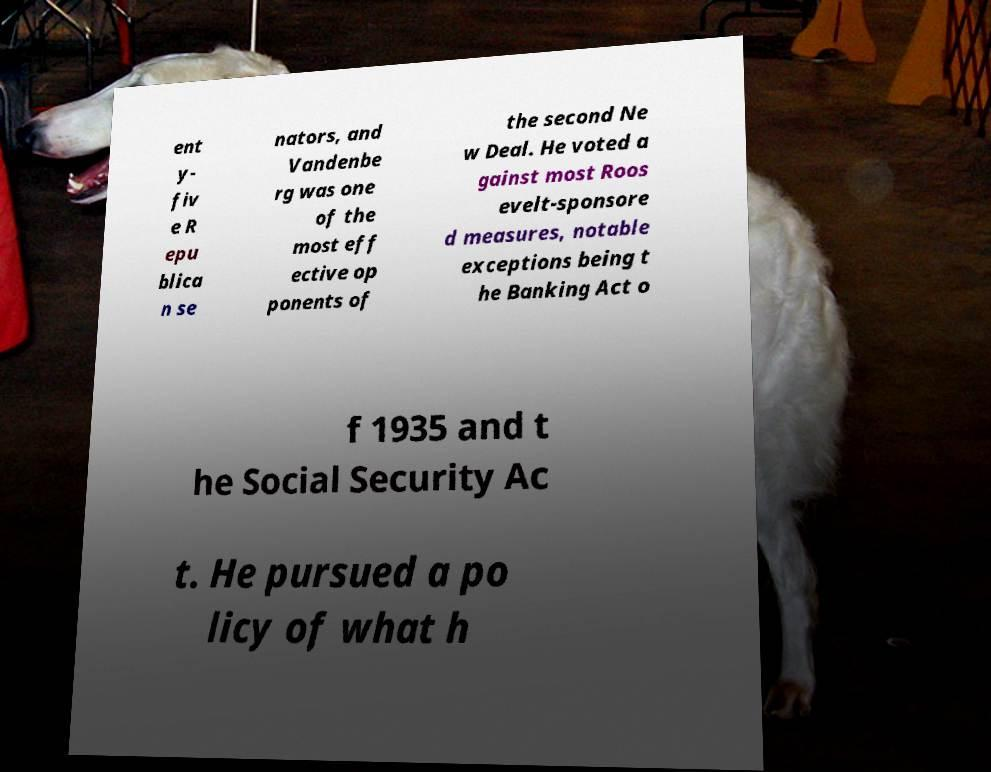Could you assist in decoding the text presented in this image and type it out clearly? ent y- fiv e R epu blica n se nators, and Vandenbe rg was one of the most eff ective op ponents of the second Ne w Deal. He voted a gainst most Roos evelt-sponsore d measures, notable exceptions being t he Banking Act o f 1935 and t he Social Security Ac t. He pursued a po licy of what h 